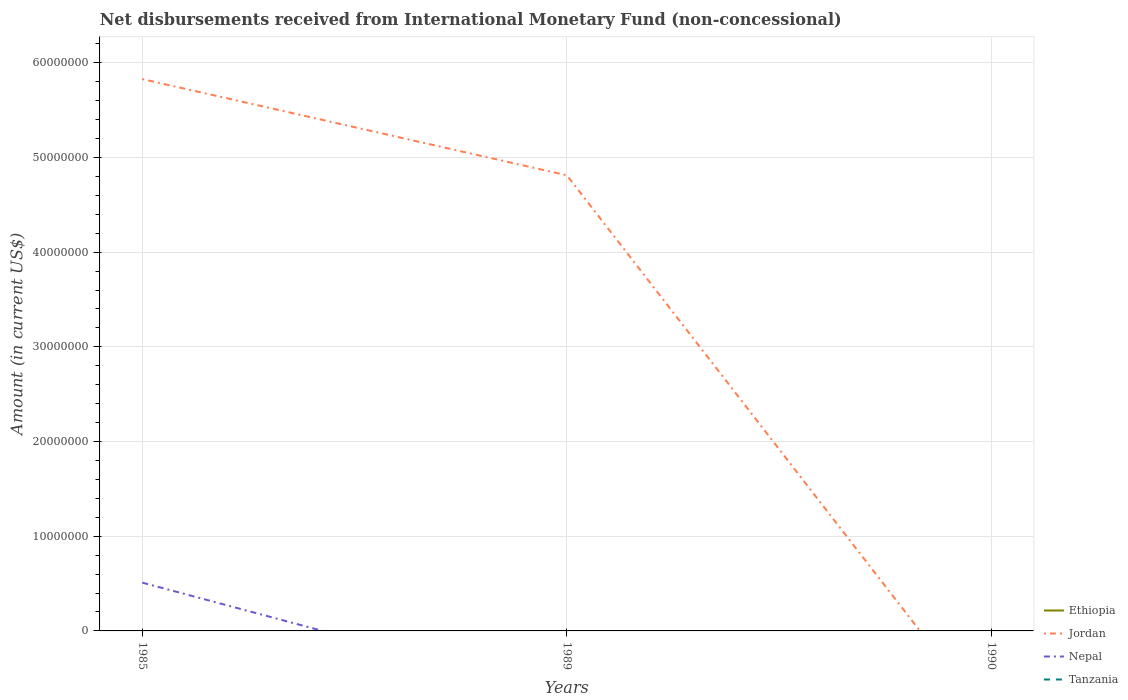Does the line corresponding to Nepal intersect with the line corresponding to Ethiopia?
Your answer should be very brief. No. Is the number of lines equal to the number of legend labels?
Keep it short and to the point. No. Across all years, what is the maximum amount of disbursements received from International Monetary Fund in Jordan?
Ensure brevity in your answer.  0. What is the total amount of disbursements received from International Monetary Fund in Jordan in the graph?
Your answer should be compact. 1.02e+07. What is the difference between the highest and the second highest amount of disbursements received from International Monetary Fund in Nepal?
Your answer should be very brief. 5.10e+06. Is the amount of disbursements received from International Monetary Fund in Jordan strictly greater than the amount of disbursements received from International Monetary Fund in Tanzania over the years?
Give a very brief answer. No. How many lines are there?
Your answer should be very brief. 2. How many years are there in the graph?
Your answer should be very brief. 3. How many legend labels are there?
Your answer should be compact. 4. How are the legend labels stacked?
Give a very brief answer. Vertical. What is the title of the graph?
Keep it short and to the point. Net disbursements received from International Monetary Fund (non-concessional). Does "Libya" appear as one of the legend labels in the graph?
Ensure brevity in your answer.  No. What is the Amount (in current US$) in Jordan in 1985?
Offer a terse response. 5.83e+07. What is the Amount (in current US$) in Nepal in 1985?
Your response must be concise. 5.10e+06. What is the Amount (in current US$) in Tanzania in 1985?
Offer a very short reply. 0. What is the Amount (in current US$) in Ethiopia in 1989?
Give a very brief answer. 0. What is the Amount (in current US$) in Jordan in 1989?
Your response must be concise. 4.81e+07. What is the Amount (in current US$) of Tanzania in 1989?
Provide a short and direct response. 0. What is the Amount (in current US$) in Ethiopia in 1990?
Give a very brief answer. 0. What is the Amount (in current US$) of Nepal in 1990?
Your answer should be compact. 0. Across all years, what is the maximum Amount (in current US$) in Jordan?
Offer a terse response. 5.83e+07. Across all years, what is the maximum Amount (in current US$) in Nepal?
Give a very brief answer. 5.10e+06. Across all years, what is the minimum Amount (in current US$) in Nepal?
Provide a succinct answer. 0. What is the total Amount (in current US$) of Jordan in the graph?
Provide a succinct answer. 1.06e+08. What is the total Amount (in current US$) in Nepal in the graph?
Provide a short and direct response. 5.10e+06. What is the difference between the Amount (in current US$) of Jordan in 1985 and that in 1989?
Keep it short and to the point. 1.02e+07. What is the average Amount (in current US$) of Ethiopia per year?
Keep it short and to the point. 0. What is the average Amount (in current US$) of Jordan per year?
Your answer should be very brief. 3.55e+07. What is the average Amount (in current US$) in Nepal per year?
Provide a short and direct response. 1.70e+06. In the year 1985, what is the difference between the Amount (in current US$) in Jordan and Amount (in current US$) in Nepal?
Provide a succinct answer. 5.32e+07. What is the ratio of the Amount (in current US$) of Jordan in 1985 to that in 1989?
Make the answer very short. 1.21. What is the difference between the highest and the lowest Amount (in current US$) of Jordan?
Make the answer very short. 5.83e+07. What is the difference between the highest and the lowest Amount (in current US$) in Nepal?
Give a very brief answer. 5.10e+06. 